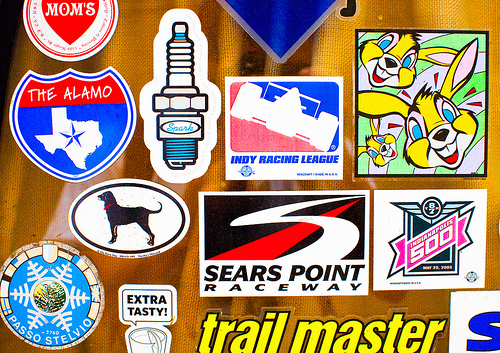<image>
Is the raceway next to the dog? Yes. The raceway is positioned adjacent to the dog, located nearby in the same general area. 